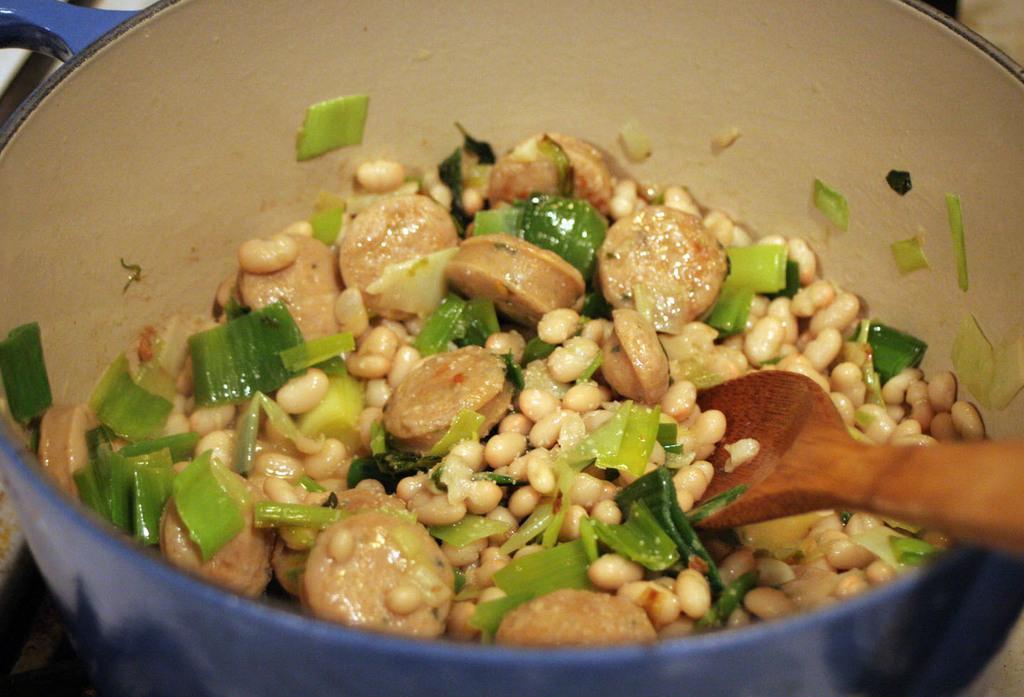Could you give a brief overview of what you see in this image? In the center of the image a food item and spoon are present in the bowl. 